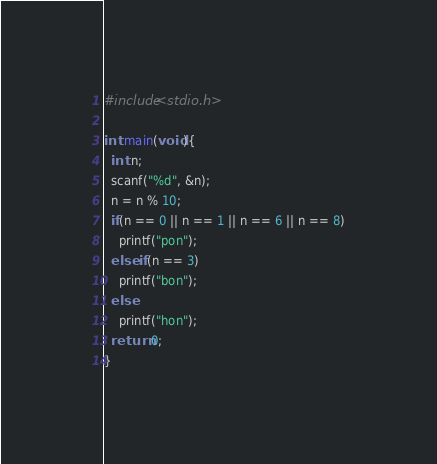Convert code to text. <code><loc_0><loc_0><loc_500><loc_500><_C_>#include<stdio.h>

int main(void){
  int n;
  scanf("%d", &n);
  n = n % 10;
  if(n == 0 || n == 1 || n == 6 || n == 8)
    printf("pon");
  else if(n == 3)
    printf("bon");
  else
    printf("hon");
  return 0;
}</code> 